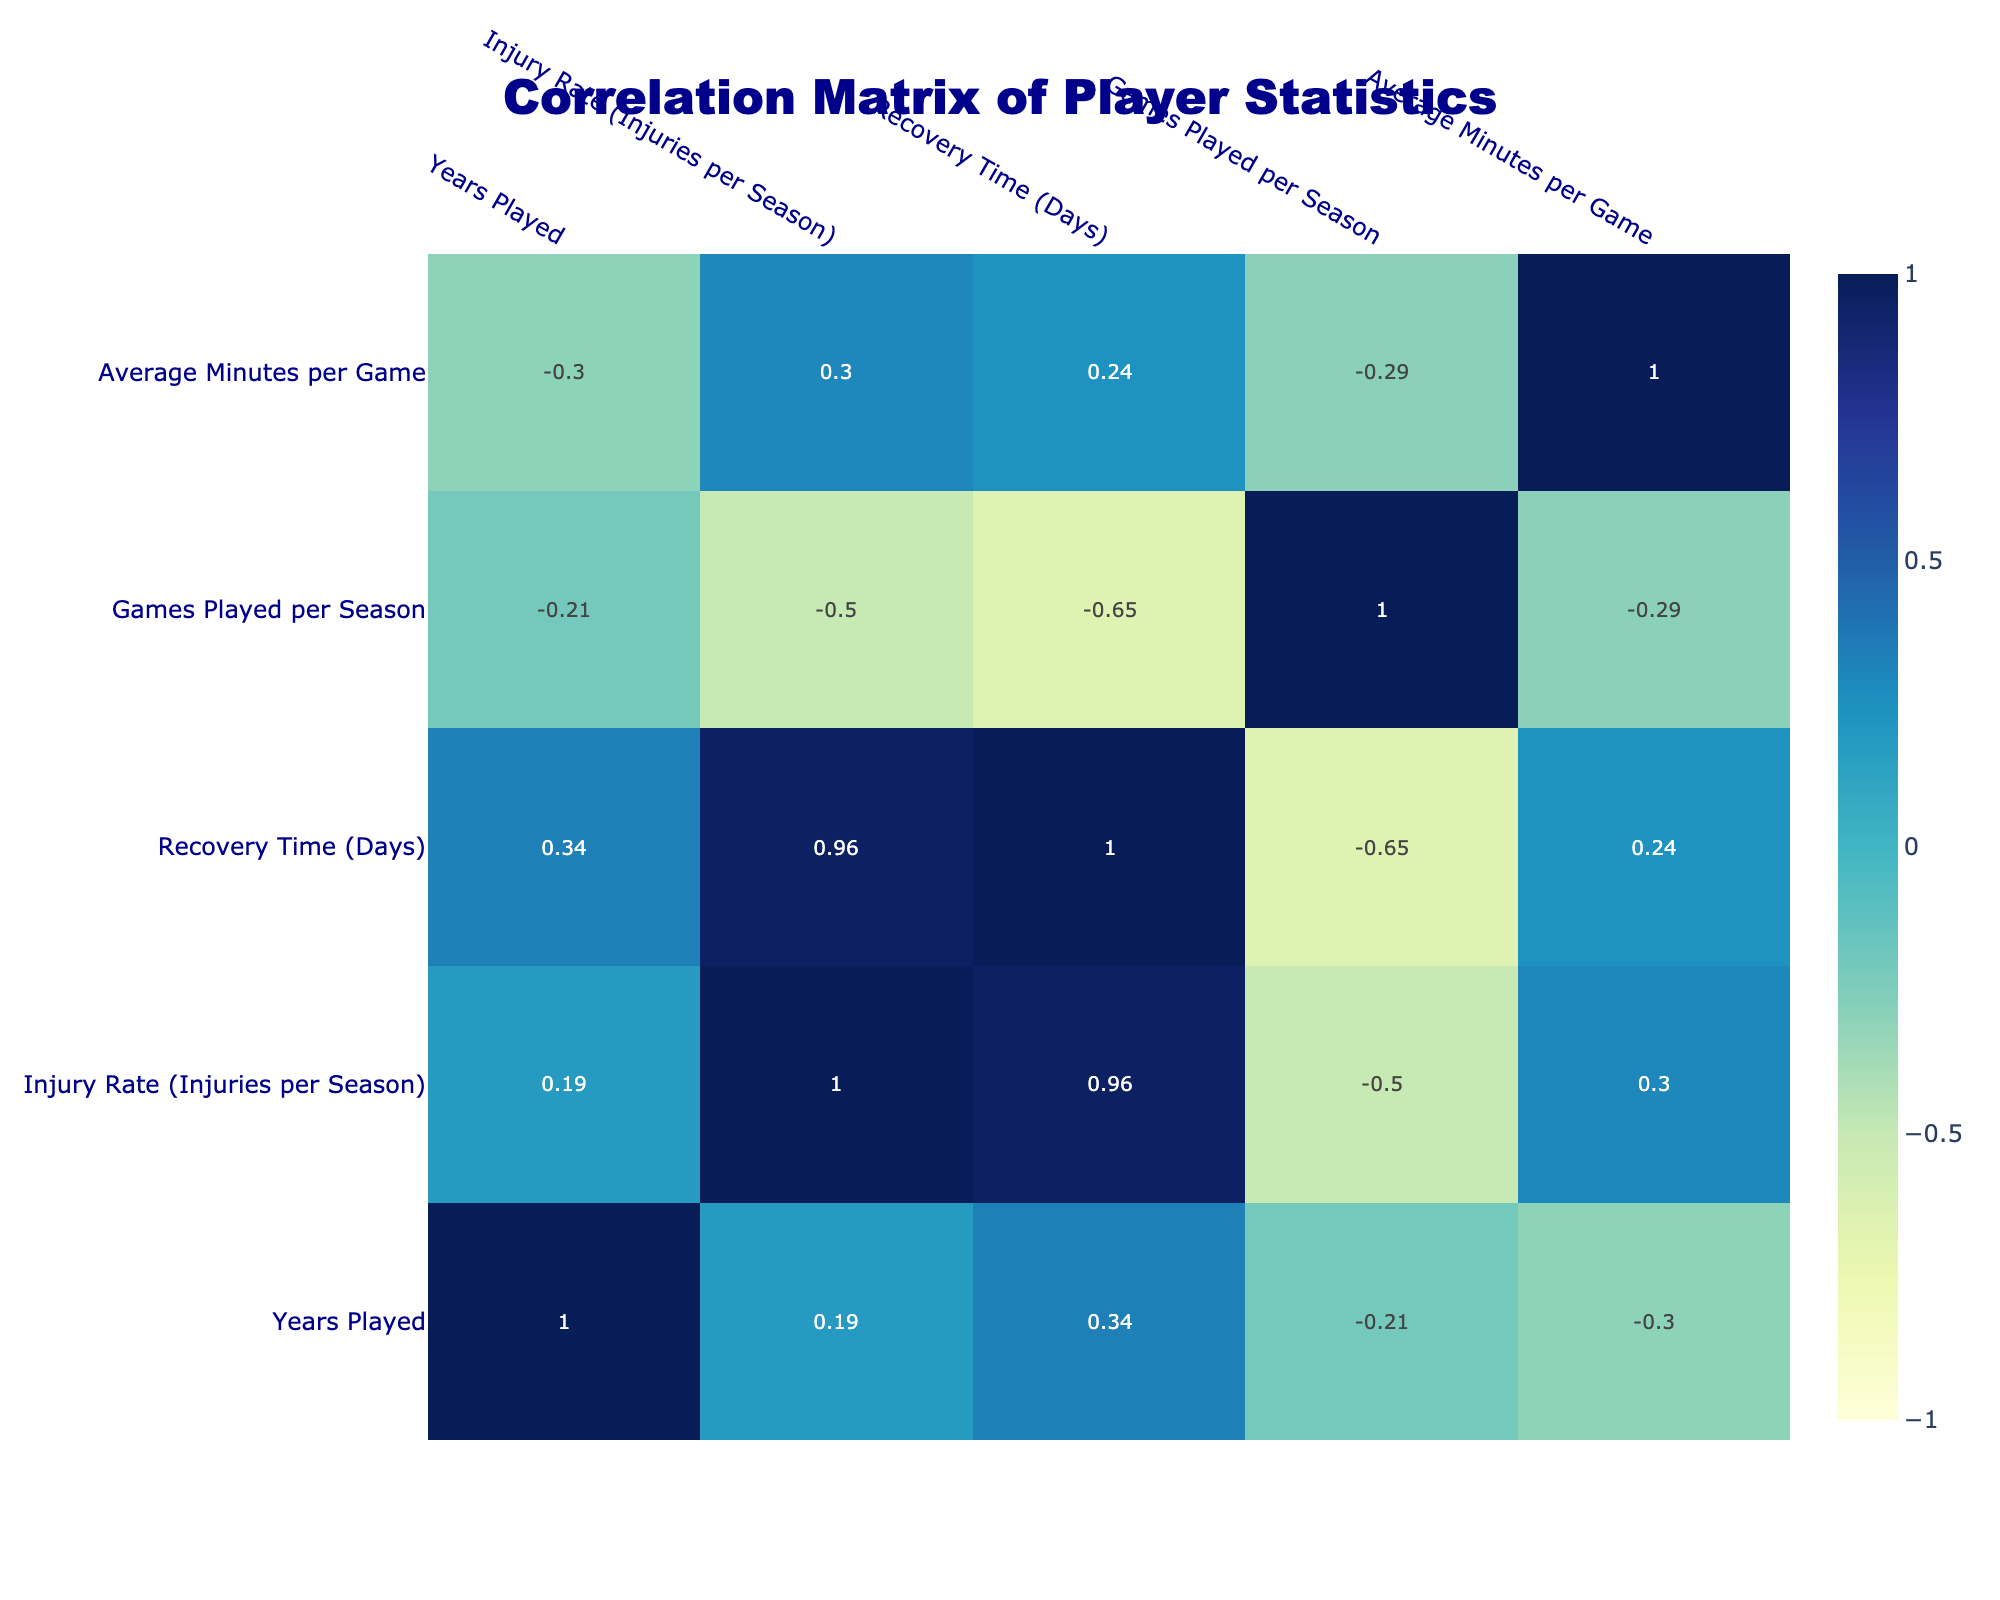What is the injury rate for Stephen Curry? From the table, I can locate Stephen Curry's row which states the injury rate as 1.2 injuries per season.
Answer: 1.2 Which player has the highest recovery time? Reviewing the recovery times in the table, James Harden has a recovery time of 14 days, which is the highest among all players listed.
Answer: 14 What is the average games played per season for players using Endurance Training? There is only one player using Endurance Training, Giannis Antetokounmpo, who plays 75 games per season. Therefore, the average equals 75.
Answer: 75 Is the average minutes per game for players with a high injury rate greater than 34? Looking at the players with high injury rates—Kevin Durant (33), Giannis Antetokounmpo (34), and James Harden (34)—the average of their minutes per game is (33 + 34 + 34) / 3 = 33.67, which is not greater than 34.
Answer: No Which training regimen type has the lowest injury rate among the players? Kawhi Leonard employs the Load Management training regimen, which has an injury rate of 0.8 injuries per season, making it the lowest compared to others listed.
Answer: Load Management What is the sum of recovery times for players using Strength and Conditioning and Flexibility and Recovery training? From the table, LeBron James (Strength and Conditioning) has a recovery time of 10 days and James Harden (Flexibility and Recovery) has 14 days. Adding these together: 10 + 14 = 24 days.
Answer: 24 How many players have played more than 70 games per season? Referring to the table, I see that LeBron James (74), Giannis Antetokounmpo (75), and Nikola Jokic (80) all have played more than 70 games, making a total of 3 players.
Answer: 3 Which player is trained under "No-Specific Training Focus" and what is his injury rate? Nikola Jokic follows the "No-Specific Training Focus" regimen, and his injury rate is 1.0 injuries per season, as stated in his row of the table.
Answer: 1.0 What is the difference in years played between the player with the least years played and the one with the most? LeBron James has the most years played at 20, while Luka Doncic has the least at 5. Thus, the difference is 20 - 5 = 15 years.
Answer: 15 